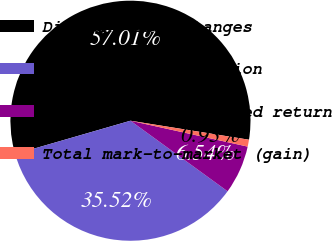Convert chart to OTSL. <chart><loc_0><loc_0><loc_500><loc_500><pie_chart><fcel>Discount rate changes<fcel>Demographic assumption<fcel>Actual versus expected return<fcel>Total mark-to-market (gain)<nl><fcel>57.01%<fcel>35.52%<fcel>6.54%<fcel>0.93%<nl></chart> 